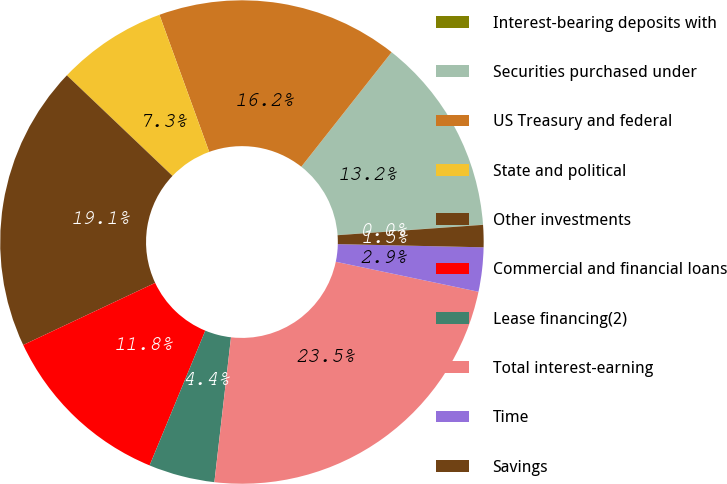Convert chart to OTSL. <chart><loc_0><loc_0><loc_500><loc_500><pie_chart><fcel>Interest-bearing deposits with<fcel>Securities purchased under<fcel>US Treasury and federal<fcel>State and political<fcel>Other investments<fcel>Commercial and financial loans<fcel>Lease financing(2)<fcel>Total interest-earning<fcel>Time<fcel>Savings<nl><fcel>0.01%<fcel>13.23%<fcel>16.17%<fcel>7.35%<fcel>19.11%<fcel>11.76%<fcel>4.42%<fcel>23.52%<fcel>2.95%<fcel>1.48%<nl></chart> 